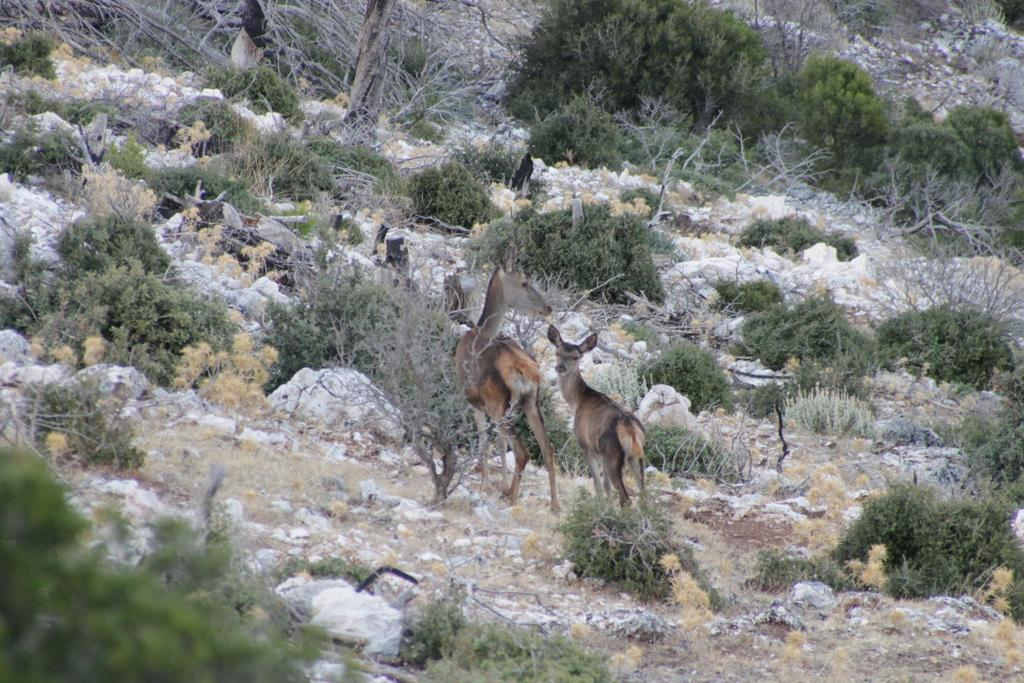How many animals are present in the image? There are two animals in the image. What else can be seen in the image besides the animals? There are stones, grass, and plants in the image. What type of chin can be seen on the farmer in the image? There is no farmer present in the image, so there is no chin to observe. 